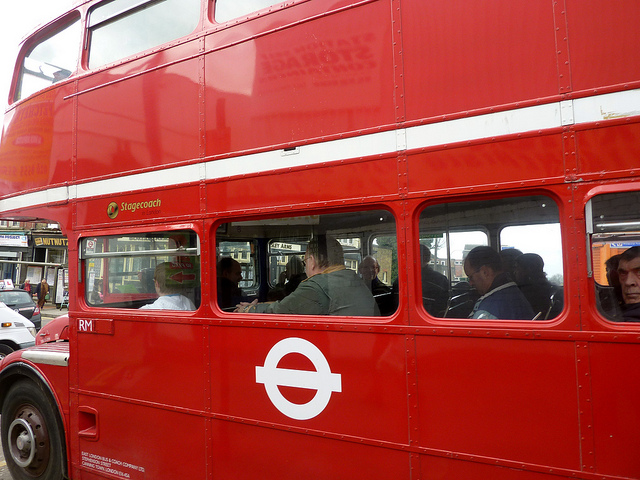<image>What is the white symbol on the red bus? I don't know what the white symbol on the red bus is. It could be a 'circle', 'circle with minus', 'logo', 'no smoking', or 'right of way'. What is the white symbol on the red bus? I am not sure what the white symbol on the red bus is. It can be any of the following: 'right of way', 'circle with minus', 'circle', 'logo', 'circle with line', 'no smoking', 'no circles'. 